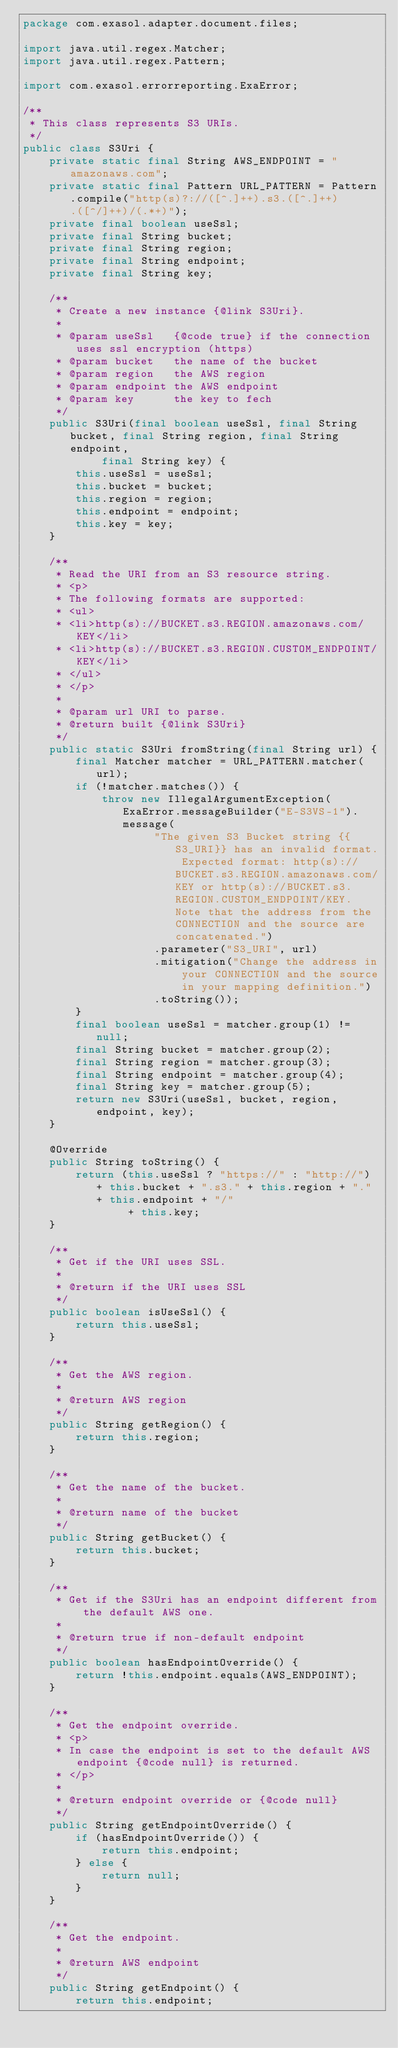<code> <loc_0><loc_0><loc_500><loc_500><_Java_>package com.exasol.adapter.document.files;

import java.util.regex.Matcher;
import java.util.regex.Pattern;

import com.exasol.errorreporting.ExaError;

/**
 * This class represents S3 URIs.
 */
public class S3Uri {
    private static final String AWS_ENDPOINT = "amazonaws.com";
    private static final Pattern URL_PATTERN = Pattern.compile("http(s)?://([^.]++).s3.([^.]++).([^/]++)/(.*+)");
    private final boolean useSsl;
    private final String bucket;
    private final String region;
    private final String endpoint;
    private final String key;

    /**
     * Create a new instance {@link S3Uri}.
     *
     * @param useSsl   {@code true} if the connection uses ssl encryption (https)
     * @param bucket   the name of the bucket
     * @param region   the AWS region
     * @param endpoint the AWS endpoint
     * @param key      the key to fech
     */
    public S3Uri(final boolean useSsl, final String bucket, final String region, final String endpoint,
            final String key) {
        this.useSsl = useSsl;
        this.bucket = bucket;
        this.region = region;
        this.endpoint = endpoint;
        this.key = key;
    }

    /**
     * Read the URI from an S3 resource string.
     * <p>
     * The following formats are supported:
     * <ul>
     * <li>http(s)://BUCKET.s3.REGION.amazonaws.com/KEY</li>
     * <li>http(s)://BUCKET.s3.REGION.CUSTOM_ENDPOINT/KEY</li>
     * </ul>
     * </p>
     *
     * @param url URI to parse.
     * @return built {@link S3Uri}
     */
    public static S3Uri fromString(final String url) {
        final Matcher matcher = URL_PATTERN.matcher(url);
        if (!matcher.matches()) {
            throw new IllegalArgumentException(ExaError.messageBuilder("E-S3VS-1").message(
                    "The given S3 Bucket string {{S3_URI}} has an invalid format. Expected format: http(s)://BUCKET.s3.REGION.amazonaws.com/KEY or http(s)://BUCKET.s3.REGION.CUSTOM_ENDPOINT/KEY. Note that the address from the CONNECTION and the source are concatenated.")
                    .parameter("S3_URI", url)
                    .mitigation("Change the address in your CONNECTION and the source in your mapping definition.")
                    .toString());
        }
        final boolean useSsl = matcher.group(1) != null;
        final String bucket = matcher.group(2);
        final String region = matcher.group(3);
        final String endpoint = matcher.group(4);
        final String key = matcher.group(5);
        return new S3Uri(useSsl, bucket, region, endpoint, key);
    }

    @Override
    public String toString() {
        return (this.useSsl ? "https://" : "http://") + this.bucket + ".s3." + this.region + "." + this.endpoint + "/"
                + this.key;
    }

    /**
     * Get if the URI uses SSL.
     *
     * @return if the URI uses SSL
     */
    public boolean isUseSsl() {
        return this.useSsl;
    }

    /**
     * Get the AWS region.
     *
     * @return AWS region
     */
    public String getRegion() {
        return this.region;
    }

    /**
     * Get the name of the bucket.
     *
     * @return name of the bucket
     */
    public String getBucket() {
        return this.bucket;
    }

    /**
     * Get if the S3Uri has an endpoint different from the default AWS one.
     *
     * @return true if non-default endpoint
     */
    public boolean hasEndpointOverride() {
        return !this.endpoint.equals(AWS_ENDPOINT);
    }

    /**
     * Get the endpoint override.
     * <p>
     * In case the endpoint is set to the default AWS endpoint {@code null} is returned.
     * </p>
     *
     * @return endpoint override or {@code null}
     */
    public String getEndpointOverride() {
        if (hasEndpointOverride()) {
            return this.endpoint;
        } else {
            return null;
        }
    }

    /**
     * Get the endpoint.
     *
     * @return AWS endpoint
     */
    public String getEndpoint() {
        return this.endpoint;</code> 